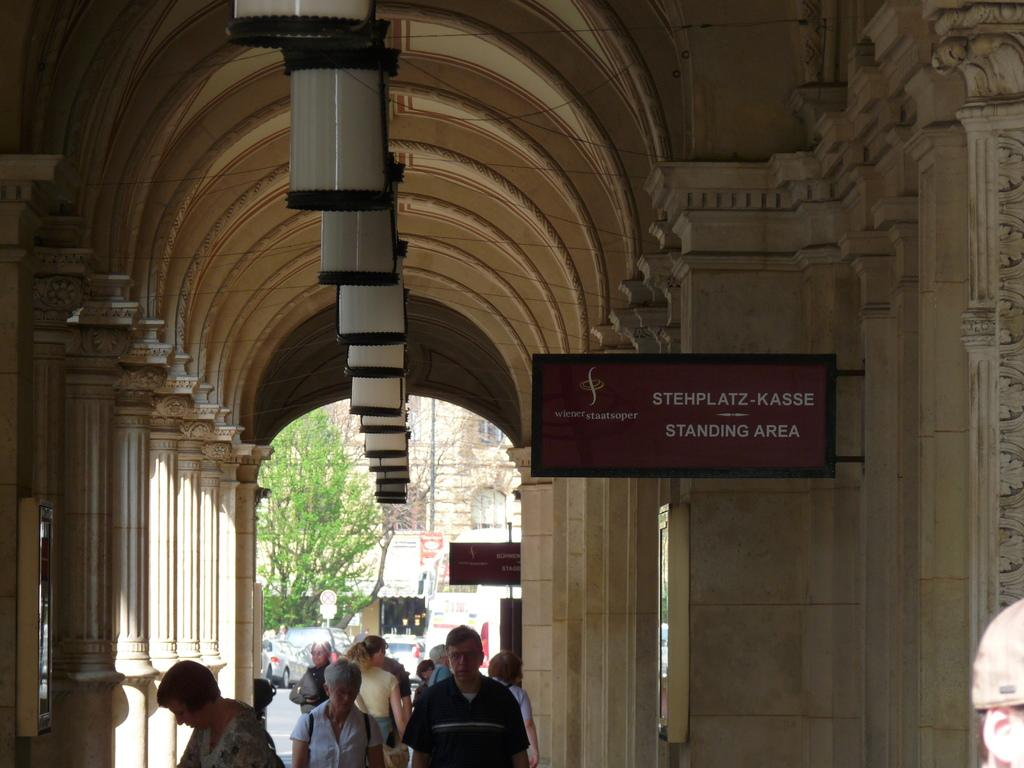How many people are in the group visible in the image? A: There is a group of people in the image, but the exact number cannot be determined from the provided facts. What can be seen near the people in the image? Name boards and pillars are visible near the people in the image. What can be seen in the background of the image? Vehicles, trees, a building with windows, and some objects are visible in the background of the image. What type of spark can be seen coming from the bear in the image? There is no bear present in the image, so there cannot be any spark coming from it. What is the purpose of the pump in the image? There is no pump present in the image, so its purpose cannot be determined. 